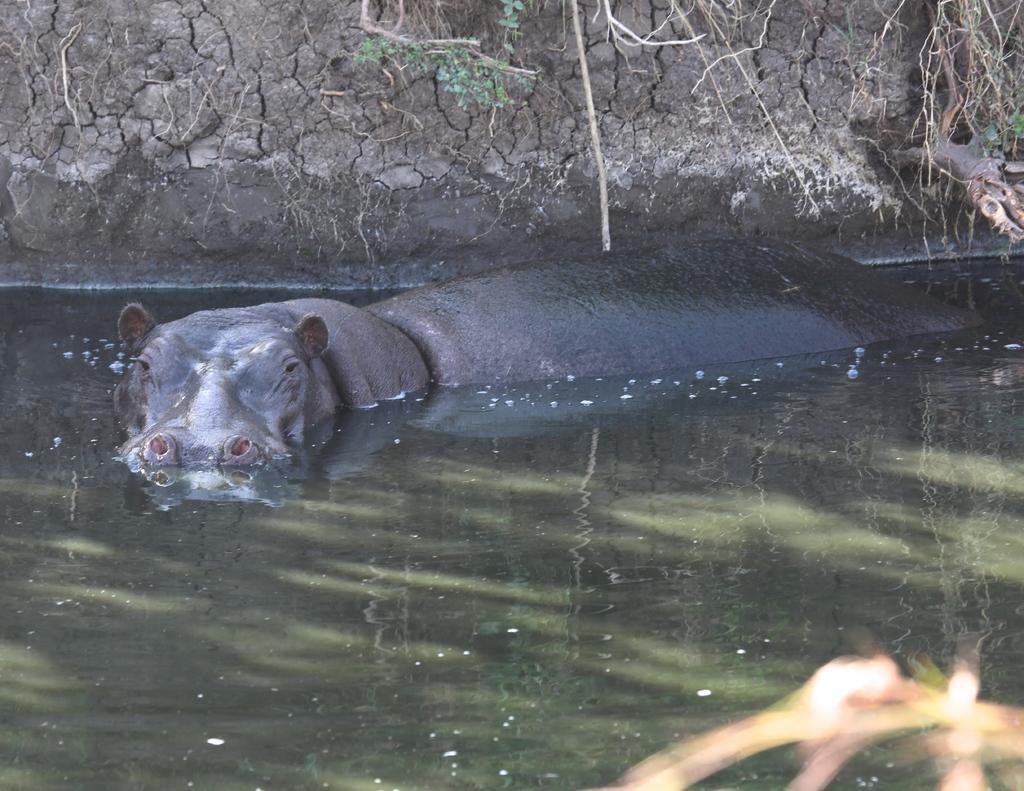In one or two sentences, can you explain what this image depicts? In this picture there is an animal in the water. At the back there is mud and there is a tree. At the bottom there is water. 